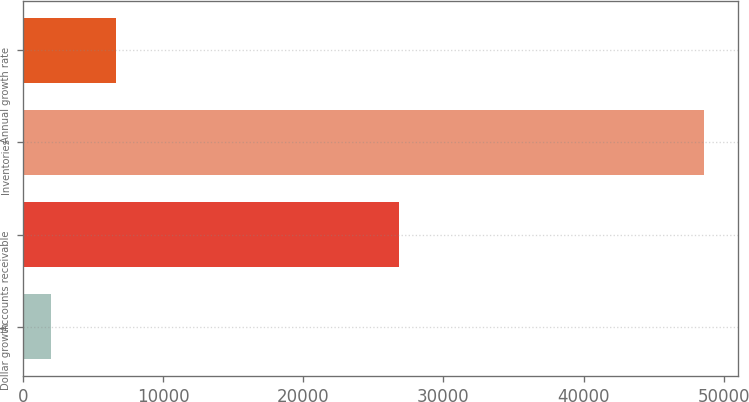Convert chart. <chart><loc_0><loc_0><loc_500><loc_500><bar_chart><fcel>Dollar growth<fcel>Accounts receivable<fcel>Inventories<fcel>Annual growth rate<nl><fcel>2007<fcel>26799<fcel>48595<fcel>6665.8<nl></chart> 